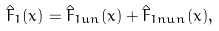<formula> <loc_0><loc_0><loc_500><loc_500>\hat { F } _ { 1 } ( x ) = \hat { F } _ { 1 u n } ( x ) + \hat { F } _ { 1 n u n } ( x ) ,</formula> 